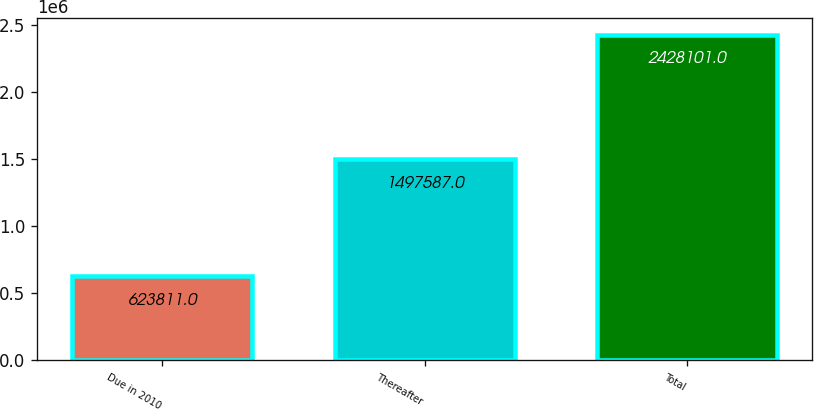Convert chart to OTSL. <chart><loc_0><loc_0><loc_500><loc_500><bar_chart><fcel>Due in 2010<fcel>Thereafter<fcel>Total<nl><fcel>623811<fcel>1.49759e+06<fcel>2.4281e+06<nl></chart> 